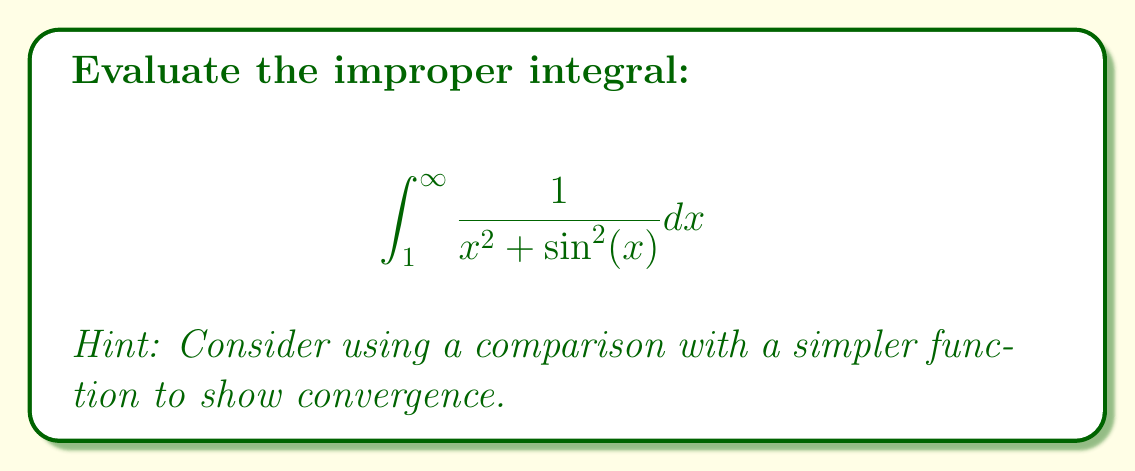Help me with this question. To evaluate this improper integral, we'll use the comparison test. Let's approach this step-by-step:

1) First, observe that for all $x \geq 1$, we have $0 \leq \sin^2(x) \leq 1$. This means:

   $$\frac{1}{x^2 + 1} \leq \frac{1}{x^2 + \sin^2(x)} \leq \frac{1}{x^2}$$

2) We know that $\int_1^{\infty} \frac{1}{x^2} dx$ converges (it equals 1). By the comparison test, this means our original integral also converges.

3) To get a more precise bound, let's compare with $\frac{1}{x^2}$:

   $$0 \leq \int_1^{\infty} \frac{1}{x^2 + \sin^2(x)} dx \leq \int_1^{\infty} \frac{1}{x^2} dx = 1$$

4) We can also get a lower bound by comparing with $\frac{1}{x^2 + 1}$:

   $$\int_1^{\infty} \frac{1}{x^2 + 1} dx \leq \int_1^{\infty} \frac{1}{x^2 + \sin^2(x)} dx \leq 1$$

5) The integral $\int_1^{\infty} \frac{1}{x^2 + 1} dx$ can be evaluated:

   $$\int_1^{\infty} \frac{1}{x^2 + 1} dx = [\arctan(x)]_1^{\infty} = \frac{\pi}{2} - \frac{\pi}{4} = \frac{\pi}{4}$$

Therefore, we can conclude:

$$\frac{\pi}{4} \leq \int_1^{\infty} \frac{1}{x^2 + \sin^2(x)} dx \leq 1$$

While we can't determine the exact value of the integral, we've shown it converges and provided tight upper and lower bounds.
Answer: The integral converges, and its value is bounded by:

$$\frac{\pi}{4} \leq \int_1^{\infty} \frac{1}{x^2 + \sin^2(x)} dx \leq 1$$ 